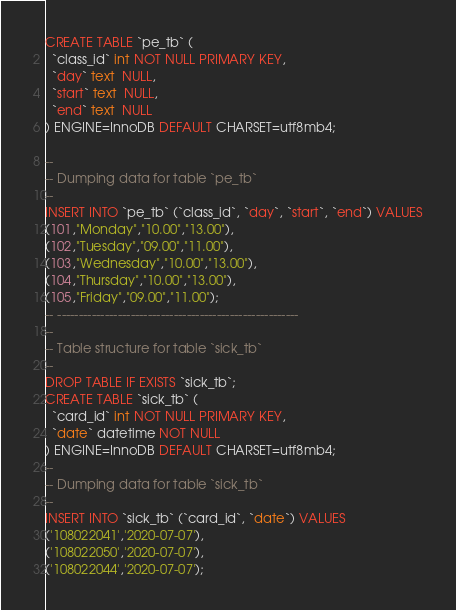Convert code to text. <code><loc_0><loc_0><loc_500><loc_500><_SQL_>CREATE TABLE `pe_tb` (
  `class_id` int NOT NULL PRIMARY KEY,
  `day` text  NULL,
  `start` text  NULL,
  `end` text  NULL
) ENGINE=InnoDB DEFAULT CHARSET=utf8mb4;

--
-- Dumping data for table `pe_tb`
--
INSERT INTO `pe_tb` (`class_id`, `day`, `start`, `end`) VALUES
(101,"Monday","10.00","13.00"),
(102,"Tuesday","09.00","11.00"),
(103,"Wednesday","10.00","13.00"),
(104,"Thursday","10.00","13.00"),
(105,"Friday","09.00","11.00");
-- --------------------------------------------------------
--
-- Table structure for table `sick_tb`
--
DROP TABLE IF EXISTS `sick_tb`;
CREATE TABLE `sick_tb` (
  `card_id` int NOT NULL PRIMARY KEY,
  `date` datetime NOT NULL
) ENGINE=InnoDB DEFAULT CHARSET=utf8mb4;
--
-- Dumping data for table `sick_tb`
--
INSERT INTO `sick_tb` (`card_id`, `date`) VALUES
('108022041','2020-07-07'),
('108022050','2020-07-07'),
('108022044','2020-07-07');</code> 